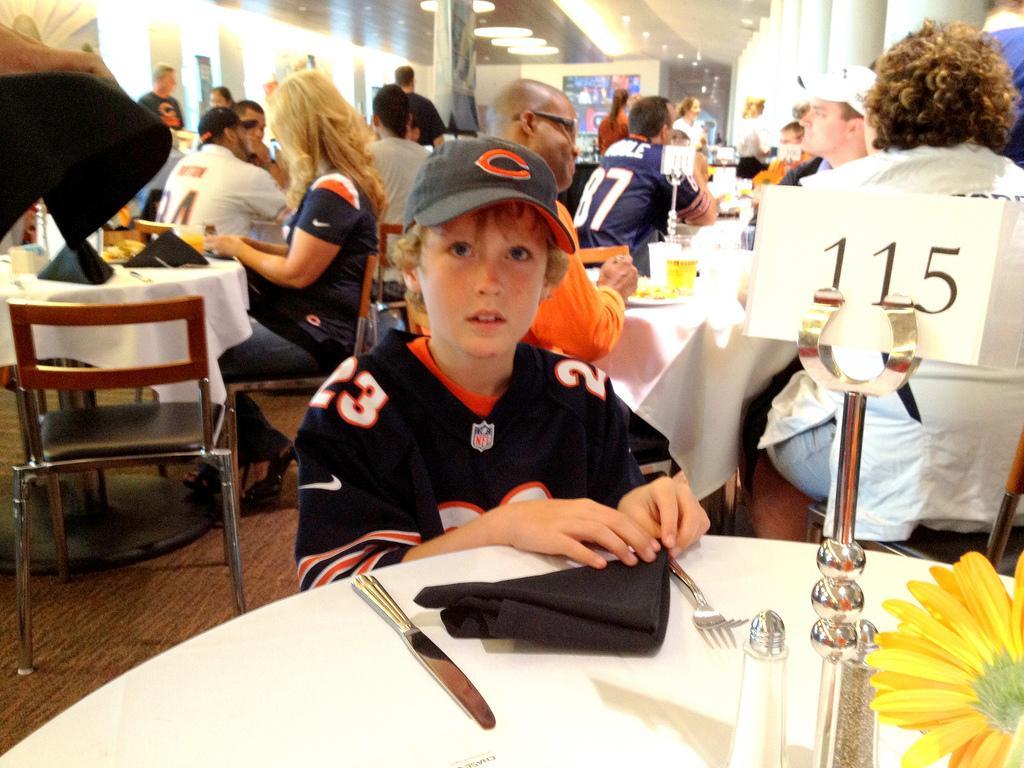Can you describe this image briefly? There is a boy wearing a black t shirt, sitting in front of a table, placing his hands on it. In front on the table, there is a black, cloth, knife and a fork. We can see here a table number 115 and a flower. He is wearing a cap. In the background there are many people sitting at their respective tables and eating their food. We can observe a pillar and ceiling lights here. 